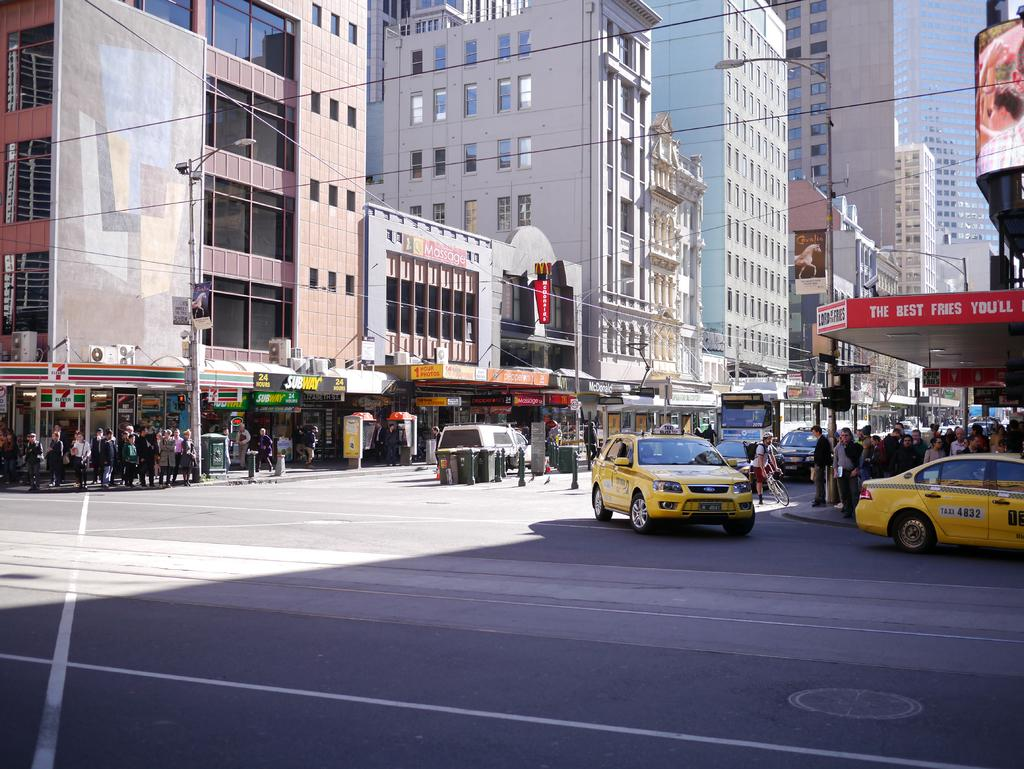<image>
Render a clear and concise summary of the photo. Yellow taxi #4832 turns the corner in front of a place that serves the Best Fries. 